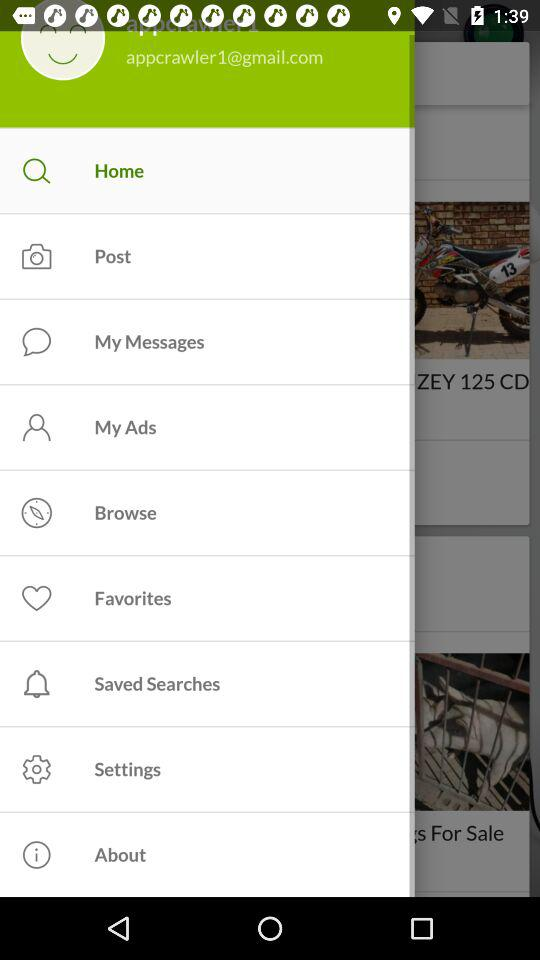What is the selected tab? The selected tab is "Home". 